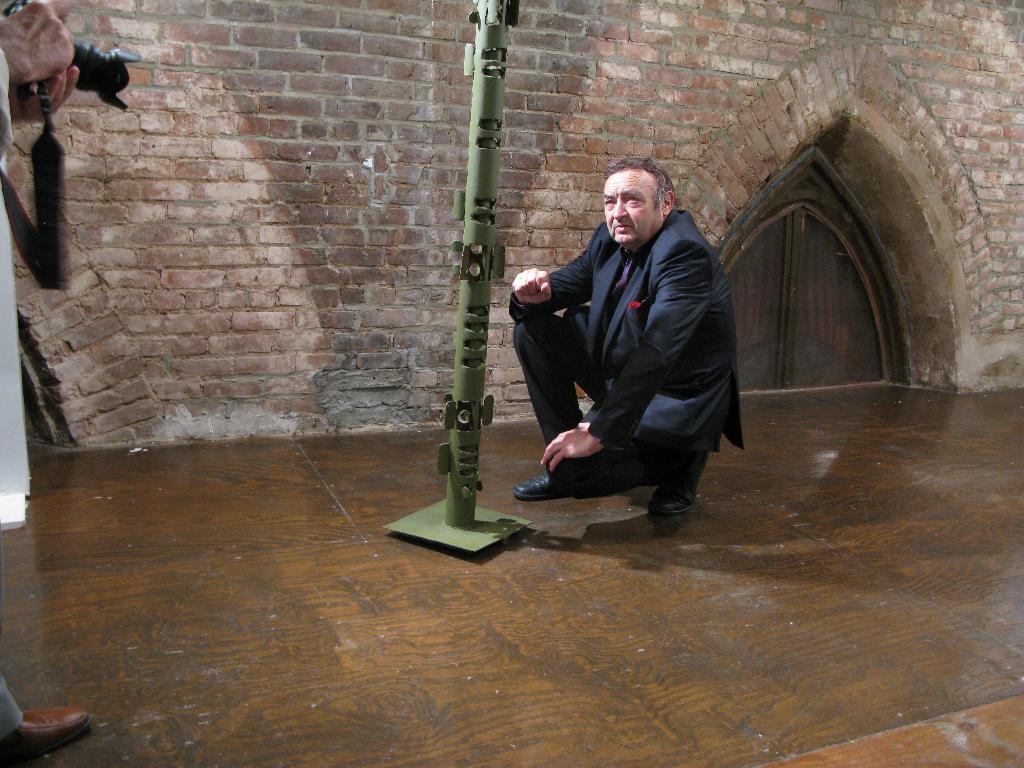Please provide a concise description of this image. In the foreground of this image, there is a person standing and holding a camera. In the middle, there is a pole and a man squatting on the wooden floor and behind him, there is a brick wall and the door. 